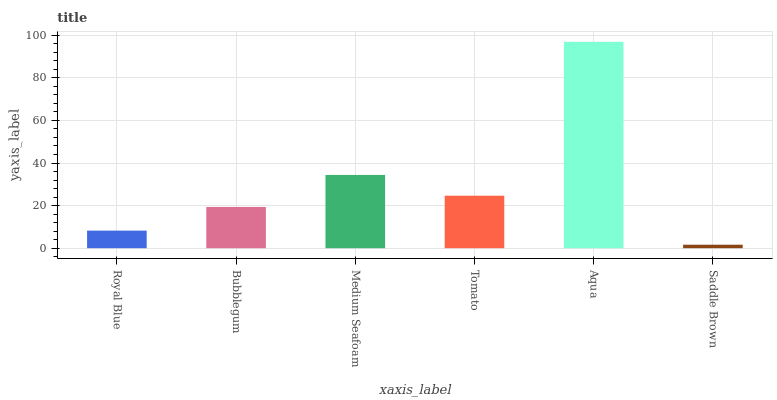Is Bubblegum the minimum?
Answer yes or no. No. Is Bubblegum the maximum?
Answer yes or no. No. Is Bubblegum greater than Royal Blue?
Answer yes or no. Yes. Is Royal Blue less than Bubblegum?
Answer yes or no. Yes. Is Royal Blue greater than Bubblegum?
Answer yes or no. No. Is Bubblegum less than Royal Blue?
Answer yes or no. No. Is Tomato the high median?
Answer yes or no. Yes. Is Bubblegum the low median?
Answer yes or no. Yes. Is Royal Blue the high median?
Answer yes or no. No. Is Royal Blue the low median?
Answer yes or no. No. 